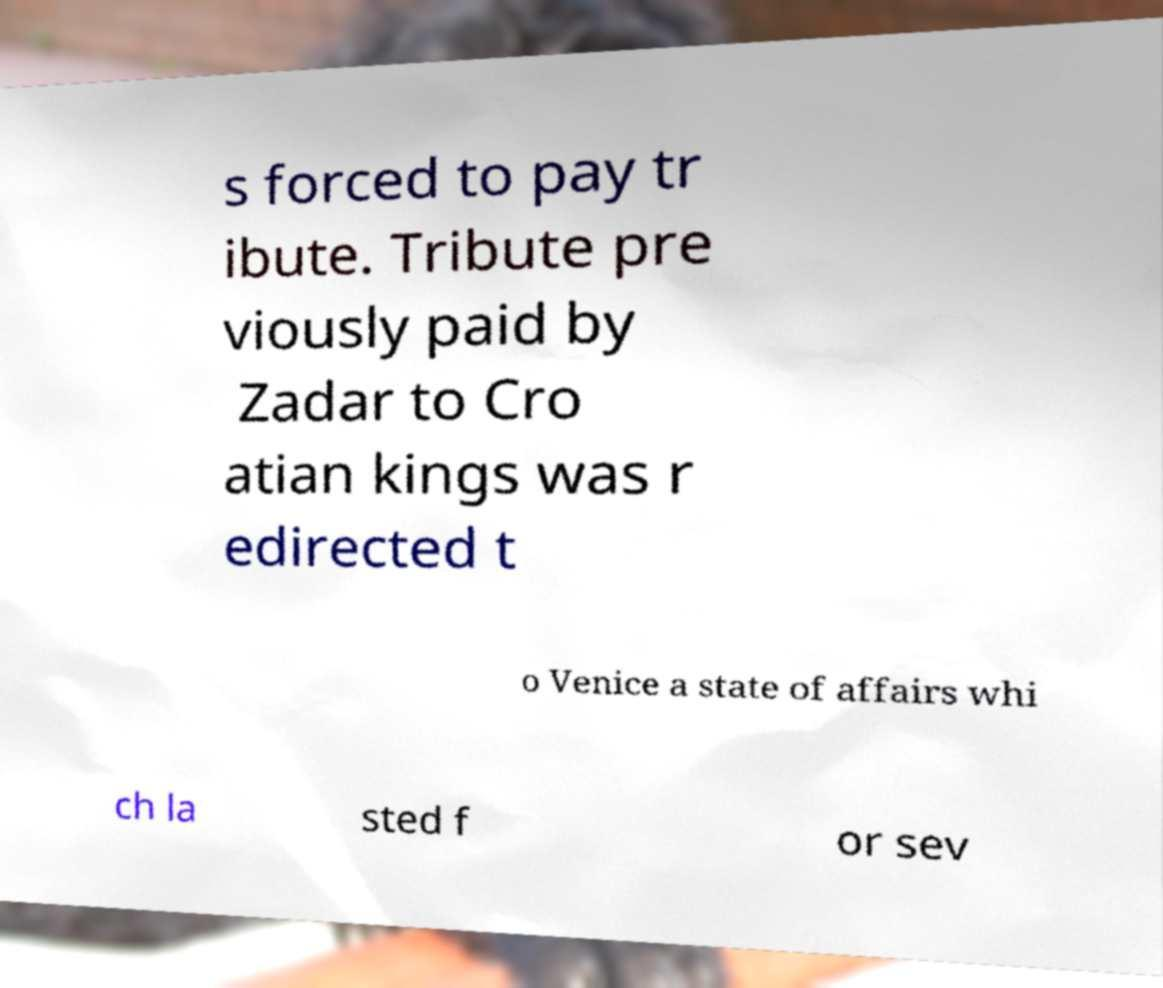Please identify and transcribe the text found in this image. s forced to pay tr ibute. Tribute pre viously paid by Zadar to Cro atian kings was r edirected t o Venice a state of affairs whi ch la sted f or sev 